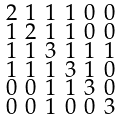<formula> <loc_0><loc_0><loc_500><loc_500>\begin{smallmatrix} 2 & 1 & 1 & 1 & 0 & 0 \\ 1 & 2 & 1 & 1 & 0 & 0 \\ 1 & 1 & 3 & 1 & 1 & 1 \\ 1 & 1 & 1 & 3 & 1 & 0 \\ 0 & 0 & 1 & 1 & 3 & 0 \\ 0 & 0 & 1 & 0 & 0 & 3 \end{smallmatrix}</formula> 